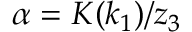<formula> <loc_0><loc_0><loc_500><loc_500>\alpha = K ( k _ { 1 } ) / z _ { 3 }</formula> 